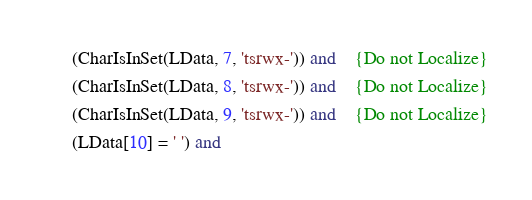<code> <loc_0><loc_0><loc_500><loc_500><_Pascal_>      (CharIsInSet(LData, 7, 'tsrwx-')) and    {Do not Localize}
      (CharIsInSet(LData, 8, 'tsrwx-')) and    {Do not Localize}
      (CharIsInSet(LData, 9, 'tsrwx-')) and    {Do not Localize}
      (LData[10] = ' ') and</code> 